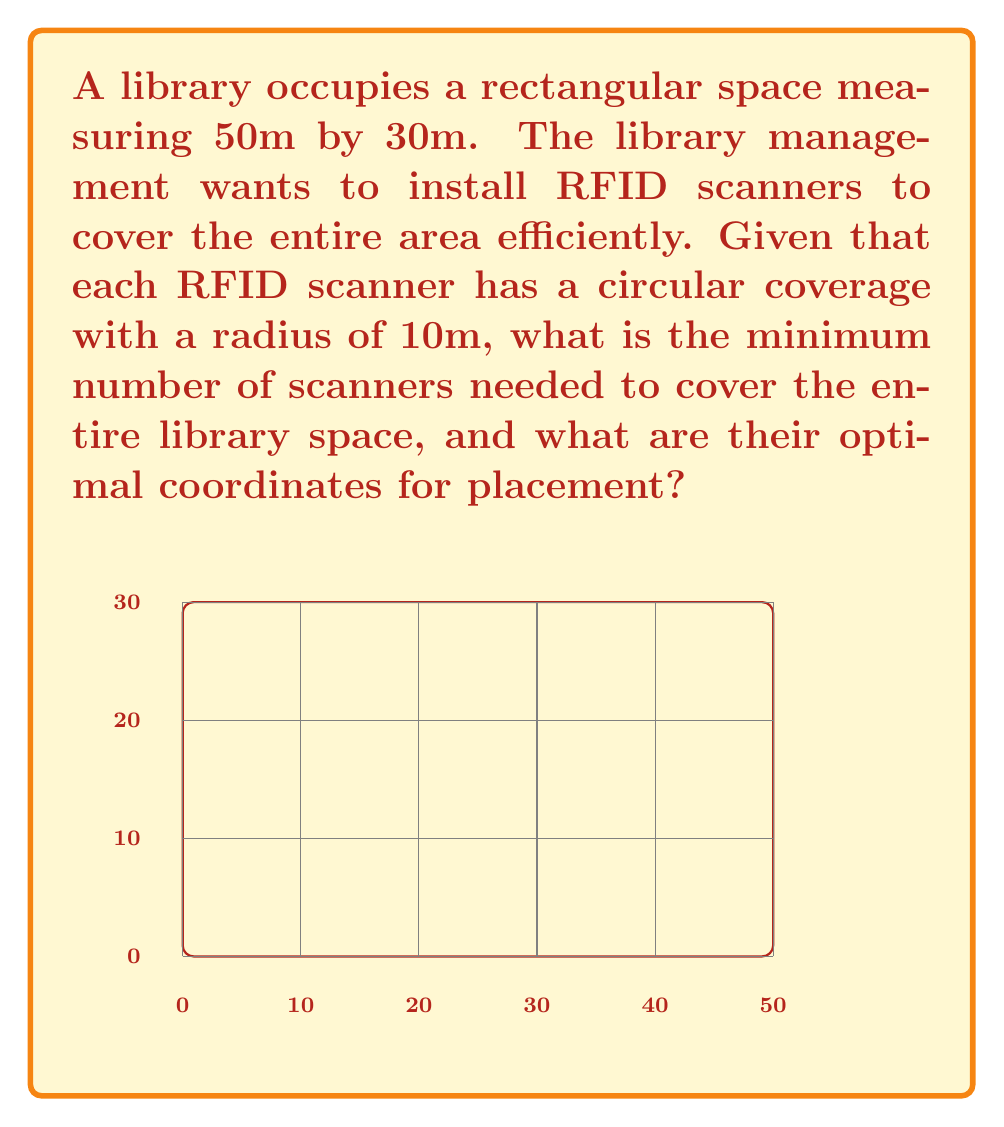Can you solve this math problem? To solve this problem, we'll use a manifold optimization approach:

1) First, we need to determine the minimum number of scanners required. We can do this by dividing the total area by the area covered by each scanner:

   Library area: $A_L = 50m \times 30m = 1500m^2$
   Scanner coverage area: $A_S = \pi r^2 = \pi (10m)^2 \approx 314.16m^2$

   Minimum number of scanners: $n = \lceil \frac{A_L}{A_S} \rceil = \lceil \frac{1500}{314.16} \rceil = 5$

2) Now, we need to optimize the placement of these 5 scanners. We can treat this as a manifold optimization problem where we're trying to minimize the uncovered area.

3) The optimization problem can be formulated as:

   $$\min_{x_1,y_1,...,x_5,y_5} \left(1500 - \sum_{i=1}^5 A_i\right)$$

   where $(x_i,y_i)$ are the coordinates of the i-th scanner, and $A_i$ is the area covered by the i-th scanner within the library space.

4) This problem is complex due to the irregular shapes formed by the intersections of circular coverage areas and the rectangular boundary. However, a good approximation can be achieved by placing the scanners in a grid-like pattern.

5) For a 50m by 30m space, an optimal configuration would be:
   - Scanner 1: (10, 10)
   - Scanner 2: (40, 10)
   - Scanner 3: (25, 20)
   - Scanner 4: (10, 30)
   - Scanner 5: (40, 30)

This configuration ensures that the entire space is covered with minimal overlap.
Answer: 5 scanners at coordinates: (10,10), (40,10), (25,20), (10,30), (40,30) 